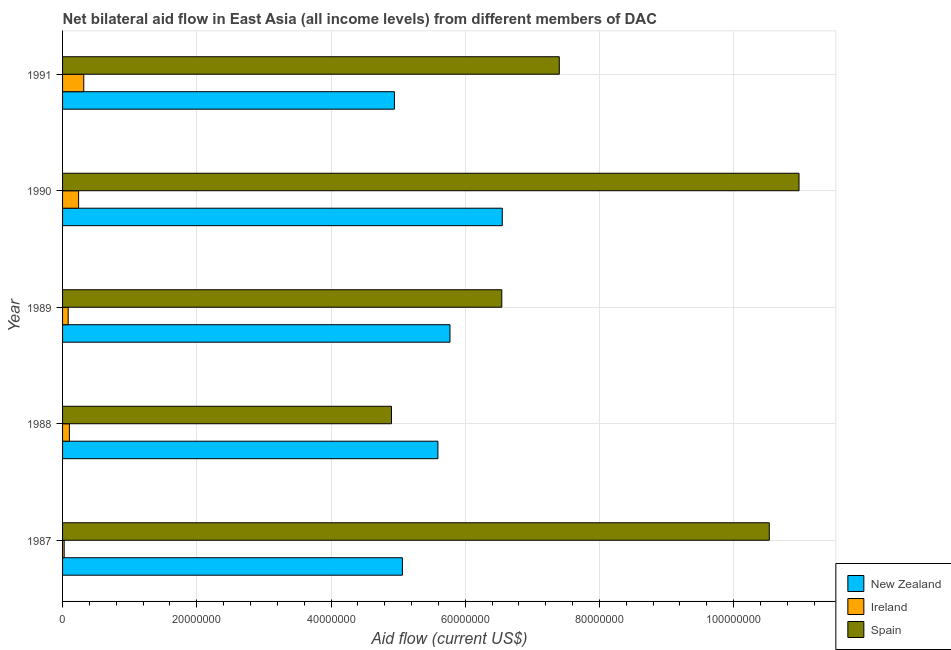How many different coloured bars are there?
Provide a succinct answer. 3. Are the number of bars per tick equal to the number of legend labels?
Your answer should be very brief. Yes. How many bars are there on the 1st tick from the top?
Your answer should be compact. 3. How many bars are there on the 2nd tick from the bottom?
Give a very brief answer. 3. In how many cases, is the number of bars for a given year not equal to the number of legend labels?
Keep it short and to the point. 0. What is the amount of aid provided by ireland in 1991?
Give a very brief answer. 3.16e+06. Across all years, what is the maximum amount of aid provided by ireland?
Ensure brevity in your answer.  3.16e+06. Across all years, what is the minimum amount of aid provided by new zealand?
Keep it short and to the point. 4.94e+07. In which year was the amount of aid provided by ireland maximum?
Ensure brevity in your answer.  1991. What is the total amount of aid provided by ireland in the graph?
Offer a very short reply. 7.65e+06. What is the difference between the amount of aid provided by new zealand in 1988 and that in 1991?
Provide a succinct answer. 6.48e+06. What is the difference between the amount of aid provided by new zealand in 1991 and the amount of aid provided by ireland in 1987?
Make the answer very short. 4.92e+07. What is the average amount of aid provided by spain per year?
Your response must be concise. 8.07e+07. In the year 1987, what is the difference between the amount of aid provided by ireland and amount of aid provided by spain?
Your response must be concise. -1.05e+08. What is the ratio of the amount of aid provided by spain in 1988 to that in 1990?
Ensure brevity in your answer.  0.45. What is the difference between the highest and the second highest amount of aid provided by spain?
Make the answer very short. 4.43e+06. What is the difference between the highest and the lowest amount of aid provided by spain?
Your response must be concise. 6.07e+07. In how many years, is the amount of aid provided by spain greater than the average amount of aid provided by spain taken over all years?
Your answer should be very brief. 2. What does the 2nd bar from the top in 1987 represents?
Your answer should be compact. Ireland. What does the 2nd bar from the bottom in 1988 represents?
Your answer should be very brief. Ireland. Is it the case that in every year, the sum of the amount of aid provided by new zealand and amount of aid provided by ireland is greater than the amount of aid provided by spain?
Offer a terse response. No. How many bars are there?
Offer a terse response. 15. How many years are there in the graph?
Make the answer very short. 5. Does the graph contain any zero values?
Your answer should be compact. No. Where does the legend appear in the graph?
Your response must be concise. Bottom right. What is the title of the graph?
Offer a terse response. Net bilateral aid flow in East Asia (all income levels) from different members of DAC. Does "Poland" appear as one of the legend labels in the graph?
Your answer should be compact. No. What is the label or title of the X-axis?
Your answer should be very brief. Aid flow (current US$). What is the Aid flow (current US$) in New Zealand in 1987?
Keep it short and to the point. 5.06e+07. What is the Aid flow (current US$) in Ireland in 1987?
Offer a terse response. 2.40e+05. What is the Aid flow (current US$) in Spain in 1987?
Give a very brief answer. 1.05e+08. What is the Aid flow (current US$) in New Zealand in 1988?
Offer a very short reply. 5.59e+07. What is the Aid flow (current US$) of Ireland in 1988?
Give a very brief answer. 1.02e+06. What is the Aid flow (current US$) of Spain in 1988?
Provide a succinct answer. 4.90e+07. What is the Aid flow (current US$) in New Zealand in 1989?
Make the answer very short. 5.77e+07. What is the Aid flow (current US$) in Ireland in 1989?
Make the answer very short. 8.40e+05. What is the Aid flow (current US$) in Spain in 1989?
Your answer should be compact. 6.54e+07. What is the Aid flow (current US$) in New Zealand in 1990?
Your answer should be very brief. 6.55e+07. What is the Aid flow (current US$) in Ireland in 1990?
Provide a succinct answer. 2.39e+06. What is the Aid flow (current US$) in Spain in 1990?
Your answer should be very brief. 1.10e+08. What is the Aid flow (current US$) in New Zealand in 1991?
Make the answer very short. 4.94e+07. What is the Aid flow (current US$) of Ireland in 1991?
Make the answer very short. 3.16e+06. What is the Aid flow (current US$) of Spain in 1991?
Make the answer very short. 7.40e+07. Across all years, what is the maximum Aid flow (current US$) in New Zealand?
Offer a terse response. 6.55e+07. Across all years, what is the maximum Aid flow (current US$) in Ireland?
Offer a very short reply. 3.16e+06. Across all years, what is the maximum Aid flow (current US$) in Spain?
Give a very brief answer. 1.10e+08. Across all years, what is the minimum Aid flow (current US$) in New Zealand?
Your answer should be compact. 4.94e+07. Across all years, what is the minimum Aid flow (current US$) in Ireland?
Your response must be concise. 2.40e+05. Across all years, what is the minimum Aid flow (current US$) in Spain?
Give a very brief answer. 4.90e+07. What is the total Aid flow (current US$) of New Zealand in the graph?
Keep it short and to the point. 2.79e+08. What is the total Aid flow (current US$) of Ireland in the graph?
Provide a succinct answer. 7.65e+06. What is the total Aid flow (current US$) of Spain in the graph?
Provide a succinct answer. 4.04e+08. What is the difference between the Aid flow (current US$) in New Zealand in 1987 and that in 1988?
Offer a terse response. -5.29e+06. What is the difference between the Aid flow (current US$) in Ireland in 1987 and that in 1988?
Offer a terse response. -7.80e+05. What is the difference between the Aid flow (current US$) in Spain in 1987 and that in 1988?
Make the answer very short. 5.63e+07. What is the difference between the Aid flow (current US$) in New Zealand in 1987 and that in 1989?
Ensure brevity in your answer.  -7.09e+06. What is the difference between the Aid flow (current US$) in Ireland in 1987 and that in 1989?
Your answer should be compact. -6.00e+05. What is the difference between the Aid flow (current US$) in Spain in 1987 and that in 1989?
Keep it short and to the point. 3.99e+07. What is the difference between the Aid flow (current US$) of New Zealand in 1987 and that in 1990?
Ensure brevity in your answer.  -1.49e+07. What is the difference between the Aid flow (current US$) in Ireland in 1987 and that in 1990?
Your response must be concise. -2.15e+06. What is the difference between the Aid flow (current US$) in Spain in 1987 and that in 1990?
Your response must be concise. -4.43e+06. What is the difference between the Aid flow (current US$) of New Zealand in 1987 and that in 1991?
Offer a terse response. 1.19e+06. What is the difference between the Aid flow (current US$) of Ireland in 1987 and that in 1991?
Offer a very short reply. -2.92e+06. What is the difference between the Aid flow (current US$) of Spain in 1987 and that in 1991?
Your answer should be compact. 3.13e+07. What is the difference between the Aid flow (current US$) of New Zealand in 1988 and that in 1989?
Keep it short and to the point. -1.80e+06. What is the difference between the Aid flow (current US$) in Spain in 1988 and that in 1989?
Provide a succinct answer. -1.64e+07. What is the difference between the Aid flow (current US$) of New Zealand in 1988 and that in 1990?
Ensure brevity in your answer.  -9.59e+06. What is the difference between the Aid flow (current US$) in Ireland in 1988 and that in 1990?
Your response must be concise. -1.37e+06. What is the difference between the Aid flow (current US$) of Spain in 1988 and that in 1990?
Offer a very short reply. -6.07e+07. What is the difference between the Aid flow (current US$) in New Zealand in 1988 and that in 1991?
Provide a short and direct response. 6.48e+06. What is the difference between the Aid flow (current US$) of Ireland in 1988 and that in 1991?
Offer a very short reply. -2.14e+06. What is the difference between the Aid flow (current US$) in Spain in 1988 and that in 1991?
Your answer should be very brief. -2.50e+07. What is the difference between the Aid flow (current US$) in New Zealand in 1989 and that in 1990?
Make the answer very short. -7.79e+06. What is the difference between the Aid flow (current US$) of Ireland in 1989 and that in 1990?
Give a very brief answer. -1.55e+06. What is the difference between the Aid flow (current US$) in Spain in 1989 and that in 1990?
Provide a short and direct response. -4.43e+07. What is the difference between the Aid flow (current US$) in New Zealand in 1989 and that in 1991?
Your answer should be very brief. 8.28e+06. What is the difference between the Aid flow (current US$) in Ireland in 1989 and that in 1991?
Give a very brief answer. -2.32e+06. What is the difference between the Aid flow (current US$) in Spain in 1989 and that in 1991?
Make the answer very short. -8.57e+06. What is the difference between the Aid flow (current US$) of New Zealand in 1990 and that in 1991?
Offer a very short reply. 1.61e+07. What is the difference between the Aid flow (current US$) of Ireland in 1990 and that in 1991?
Give a very brief answer. -7.70e+05. What is the difference between the Aid flow (current US$) in Spain in 1990 and that in 1991?
Provide a succinct answer. 3.57e+07. What is the difference between the Aid flow (current US$) in New Zealand in 1987 and the Aid flow (current US$) in Ireland in 1988?
Provide a short and direct response. 4.96e+07. What is the difference between the Aid flow (current US$) of New Zealand in 1987 and the Aid flow (current US$) of Spain in 1988?
Ensure brevity in your answer.  1.63e+06. What is the difference between the Aid flow (current US$) of Ireland in 1987 and the Aid flow (current US$) of Spain in 1988?
Offer a terse response. -4.88e+07. What is the difference between the Aid flow (current US$) of New Zealand in 1987 and the Aid flow (current US$) of Ireland in 1989?
Make the answer very short. 4.98e+07. What is the difference between the Aid flow (current US$) in New Zealand in 1987 and the Aid flow (current US$) in Spain in 1989?
Provide a short and direct response. -1.48e+07. What is the difference between the Aid flow (current US$) of Ireland in 1987 and the Aid flow (current US$) of Spain in 1989?
Your answer should be very brief. -6.52e+07. What is the difference between the Aid flow (current US$) of New Zealand in 1987 and the Aid flow (current US$) of Ireland in 1990?
Offer a very short reply. 4.82e+07. What is the difference between the Aid flow (current US$) in New Zealand in 1987 and the Aid flow (current US$) in Spain in 1990?
Your response must be concise. -5.91e+07. What is the difference between the Aid flow (current US$) in Ireland in 1987 and the Aid flow (current US$) in Spain in 1990?
Your answer should be very brief. -1.10e+08. What is the difference between the Aid flow (current US$) in New Zealand in 1987 and the Aid flow (current US$) in Ireland in 1991?
Offer a terse response. 4.75e+07. What is the difference between the Aid flow (current US$) in New Zealand in 1987 and the Aid flow (current US$) in Spain in 1991?
Your answer should be compact. -2.34e+07. What is the difference between the Aid flow (current US$) in Ireland in 1987 and the Aid flow (current US$) in Spain in 1991?
Offer a very short reply. -7.38e+07. What is the difference between the Aid flow (current US$) of New Zealand in 1988 and the Aid flow (current US$) of Ireland in 1989?
Ensure brevity in your answer.  5.51e+07. What is the difference between the Aid flow (current US$) in New Zealand in 1988 and the Aid flow (current US$) in Spain in 1989?
Offer a very short reply. -9.52e+06. What is the difference between the Aid flow (current US$) of Ireland in 1988 and the Aid flow (current US$) of Spain in 1989?
Provide a short and direct response. -6.44e+07. What is the difference between the Aid flow (current US$) of New Zealand in 1988 and the Aid flow (current US$) of Ireland in 1990?
Provide a succinct answer. 5.35e+07. What is the difference between the Aid flow (current US$) in New Zealand in 1988 and the Aid flow (current US$) in Spain in 1990?
Provide a succinct answer. -5.38e+07. What is the difference between the Aid flow (current US$) of Ireland in 1988 and the Aid flow (current US$) of Spain in 1990?
Give a very brief answer. -1.09e+08. What is the difference between the Aid flow (current US$) in New Zealand in 1988 and the Aid flow (current US$) in Ireland in 1991?
Your answer should be compact. 5.28e+07. What is the difference between the Aid flow (current US$) of New Zealand in 1988 and the Aid flow (current US$) of Spain in 1991?
Ensure brevity in your answer.  -1.81e+07. What is the difference between the Aid flow (current US$) of Ireland in 1988 and the Aid flow (current US$) of Spain in 1991?
Your answer should be compact. -7.30e+07. What is the difference between the Aid flow (current US$) of New Zealand in 1989 and the Aid flow (current US$) of Ireland in 1990?
Make the answer very short. 5.53e+07. What is the difference between the Aid flow (current US$) in New Zealand in 1989 and the Aid flow (current US$) in Spain in 1990?
Give a very brief answer. -5.20e+07. What is the difference between the Aid flow (current US$) in Ireland in 1989 and the Aid flow (current US$) in Spain in 1990?
Make the answer very short. -1.09e+08. What is the difference between the Aid flow (current US$) of New Zealand in 1989 and the Aid flow (current US$) of Ireland in 1991?
Provide a succinct answer. 5.46e+07. What is the difference between the Aid flow (current US$) in New Zealand in 1989 and the Aid flow (current US$) in Spain in 1991?
Offer a very short reply. -1.63e+07. What is the difference between the Aid flow (current US$) of Ireland in 1989 and the Aid flow (current US$) of Spain in 1991?
Provide a succinct answer. -7.32e+07. What is the difference between the Aid flow (current US$) of New Zealand in 1990 and the Aid flow (current US$) of Ireland in 1991?
Keep it short and to the point. 6.24e+07. What is the difference between the Aid flow (current US$) of New Zealand in 1990 and the Aid flow (current US$) of Spain in 1991?
Provide a succinct answer. -8.50e+06. What is the difference between the Aid flow (current US$) of Ireland in 1990 and the Aid flow (current US$) of Spain in 1991?
Your answer should be very brief. -7.16e+07. What is the average Aid flow (current US$) of New Zealand per year?
Offer a very short reply. 5.59e+07. What is the average Aid flow (current US$) in Ireland per year?
Your response must be concise. 1.53e+06. What is the average Aid flow (current US$) of Spain per year?
Provide a short and direct response. 8.07e+07. In the year 1987, what is the difference between the Aid flow (current US$) of New Zealand and Aid flow (current US$) of Ireland?
Keep it short and to the point. 5.04e+07. In the year 1987, what is the difference between the Aid flow (current US$) in New Zealand and Aid flow (current US$) in Spain?
Make the answer very short. -5.47e+07. In the year 1987, what is the difference between the Aid flow (current US$) in Ireland and Aid flow (current US$) in Spain?
Your answer should be very brief. -1.05e+08. In the year 1988, what is the difference between the Aid flow (current US$) of New Zealand and Aid flow (current US$) of Ireland?
Ensure brevity in your answer.  5.49e+07. In the year 1988, what is the difference between the Aid flow (current US$) in New Zealand and Aid flow (current US$) in Spain?
Offer a terse response. 6.92e+06. In the year 1988, what is the difference between the Aid flow (current US$) in Ireland and Aid flow (current US$) in Spain?
Keep it short and to the point. -4.80e+07. In the year 1989, what is the difference between the Aid flow (current US$) of New Zealand and Aid flow (current US$) of Ireland?
Ensure brevity in your answer.  5.69e+07. In the year 1989, what is the difference between the Aid flow (current US$) in New Zealand and Aid flow (current US$) in Spain?
Provide a short and direct response. -7.72e+06. In the year 1989, what is the difference between the Aid flow (current US$) of Ireland and Aid flow (current US$) of Spain?
Provide a succinct answer. -6.46e+07. In the year 1990, what is the difference between the Aid flow (current US$) of New Zealand and Aid flow (current US$) of Ireland?
Provide a succinct answer. 6.31e+07. In the year 1990, what is the difference between the Aid flow (current US$) of New Zealand and Aid flow (current US$) of Spain?
Make the answer very short. -4.42e+07. In the year 1990, what is the difference between the Aid flow (current US$) in Ireland and Aid flow (current US$) in Spain?
Your answer should be compact. -1.07e+08. In the year 1991, what is the difference between the Aid flow (current US$) in New Zealand and Aid flow (current US$) in Ireland?
Offer a very short reply. 4.63e+07. In the year 1991, what is the difference between the Aid flow (current US$) of New Zealand and Aid flow (current US$) of Spain?
Ensure brevity in your answer.  -2.46e+07. In the year 1991, what is the difference between the Aid flow (current US$) in Ireland and Aid flow (current US$) in Spain?
Your answer should be compact. -7.09e+07. What is the ratio of the Aid flow (current US$) in New Zealand in 1987 to that in 1988?
Your answer should be very brief. 0.91. What is the ratio of the Aid flow (current US$) in Ireland in 1987 to that in 1988?
Keep it short and to the point. 0.24. What is the ratio of the Aid flow (current US$) of Spain in 1987 to that in 1988?
Offer a very short reply. 2.15. What is the ratio of the Aid flow (current US$) in New Zealand in 1987 to that in 1989?
Offer a terse response. 0.88. What is the ratio of the Aid flow (current US$) of Ireland in 1987 to that in 1989?
Your answer should be compact. 0.29. What is the ratio of the Aid flow (current US$) of Spain in 1987 to that in 1989?
Make the answer very short. 1.61. What is the ratio of the Aid flow (current US$) in New Zealand in 1987 to that in 1990?
Ensure brevity in your answer.  0.77. What is the ratio of the Aid flow (current US$) of Ireland in 1987 to that in 1990?
Your answer should be compact. 0.1. What is the ratio of the Aid flow (current US$) in Spain in 1987 to that in 1990?
Keep it short and to the point. 0.96. What is the ratio of the Aid flow (current US$) in New Zealand in 1987 to that in 1991?
Offer a terse response. 1.02. What is the ratio of the Aid flow (current US$) in Ireland in 1987 to that in 1991?
Your answer should be very brief. 0.08. What is the ratio of the Aid flow (current US$) of Spain in 1987 to that in 1991?
Offer a very short reply. 1.42. What is the ratio of the Aid flow (current US$) of New Zealand in 1988 to that in 1989?
Your response must be concise. 0.97. What is the ratio of the Aid flow (current US$) of Ireland in 1988 to that in 1989?
Keep it short and to the point. 1.21. What is the ratio of the Aid flow (current US$) of Spain in 1988 to that in 1989?
Provide a succinct answer. 0.75. What is the ratio of the Aid flow (current US$) of New Zealand in 1988 to that in 1990?
Provide a succinct answer. 0.85. What is the ratio of the Aid flow (current US$) of Ireland in 1988 to that in 1990?
Your answer should be very brief. 0.43. What is the ratio of the Aid flow (current US$) of Spain in 1988 to that in 1990?
Offer a terse response. 0.45. What is the ratio of the Aid flow (current US$) in New Zealand in 1988 to that in 1991?
Your answer should be very brief. 1.13. What is the ratio of the Aid flow (current US$) in Ireland in 1988 to that in 1991?
Your answer should be very brief. 0.32. What is the ratio of the Aid flow (current US$) in Spain in 1988 to that in 1991?
Keep it short and to the point. 0.66. What is the ratio of the Aid flow (current US$) of New Zealand in 1989 to that in 1990?
Provide a short and direct response. 0.88. What is the ratio of the Aid flow (current US$) of Ireland in 1989 to that in 1990?
Your answer should be compact. 0.35. What is the ratio of the Aid flow (current US$) of Spain in 1989 to that in 1990?
Provide a short and direct response. 0.6. What is the ratio of the Aid flow (current US$) in New Zealand in 1989 to that in 1991?
Give a very brief answer. 1.17. What is the ratio of the Aid flow (current US$) in Ireland in 1989 to that in 1991?
Provide a succinct answer. 0.27. What is the ratio of the Aid flow (current US$) in Spain in 1989 to that in 1991?
Your response must be concise. 0.88. What is the ratio of the Aid flow (current US$) in New Zealand in 1990 to that in 1991?
Ensure brevity in your answer.  1.32. What is the ratio of the Aid flow (current US$) in Ireland in 1990 to that in 1991?
Offer a terse response. 0.76. What is the ratio of the Aid flow (current US$) of Spain in 1990 to that in 1991?
Provide a succinct answer. 1.48. What is the difference between the highest and the second highest Aid flow (current US$) in New Zealand?
Give a very brief answer. 7.79e+06. What is the difference between the highest and the second highest Aid flow (current US$) of Ireland?
Offer a very short reply. 7.70e+05. What is the difference between the highest and the second highest Aid flow (current US$) in Spain?
Make the answer very short. 4.43e+06. What is the difference between the highest and the lowest Aid flow (current US$) of New Zealand?
Offer a terse response. 1.61e+07. What is the difference between the highest and the lowest Aid flow (current US$) in Ireland?
Give a very brief answer. 2.92e+06. What is the difference between the highest and the lowest Aid flow (current US$) in Spain?
Ensure brevity in your answer.  6.07e+07. 